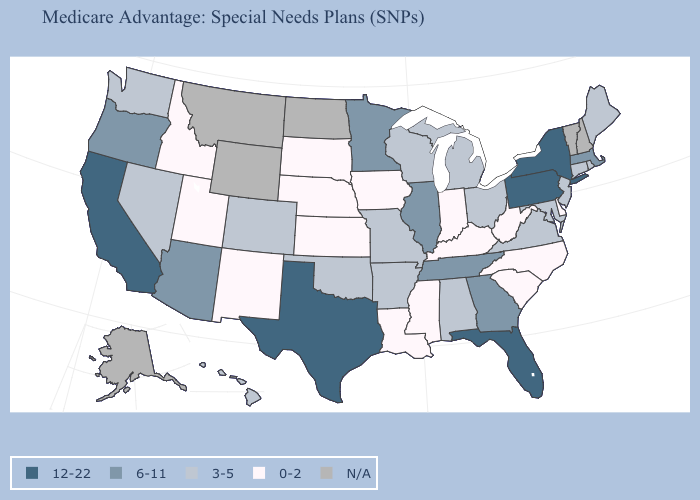What is the value of Nevada?
Short answer required. 3-5. What is the highest value in the USA?
Write a very short answer. 12-22. Does South Carolina have the highest value in the South?
Give a very brief answer. No. What is the value of Massachusetts?
Give a very brief answer. 6-11. What is the value of Idaho?
Give a very brief answer. 0-2. Does the first symbol in the legend represent the smallest category?
Give a very brief answer. No. Does West Virginia have the lowest value in the South?
Concise answer only. Yes. Among the states that border South Dakota , does Minnesota have the highest value?
Concise answer only. Yes. What is the value of Maryland?
Write a very short answer. 3-5. Does Mississippi have the lowest value in the USA?
Short answer required. Yes. Does Maine have the highest value in the USA?
Concise answer only. No. Among the states that border Alabama , which have the lowest value?
Write a very short answer. Mississippi. Which states have the lowest value in the West?
Answer briefly. Idaho, New Mexico, Utah. What is the value of Tennessee?
Concise answer only. 6-11. 